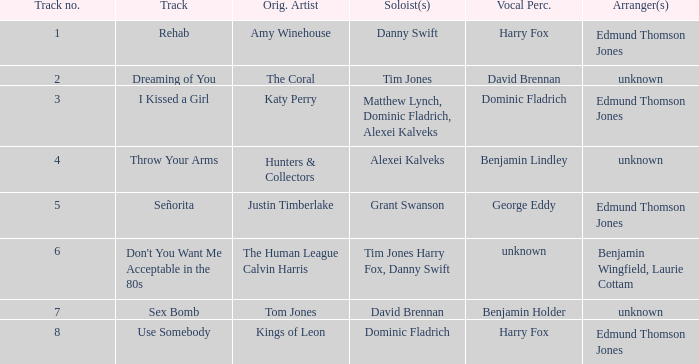Who is the arranger for "I KIssed a Girl"? Edmund Thomson Jones. 